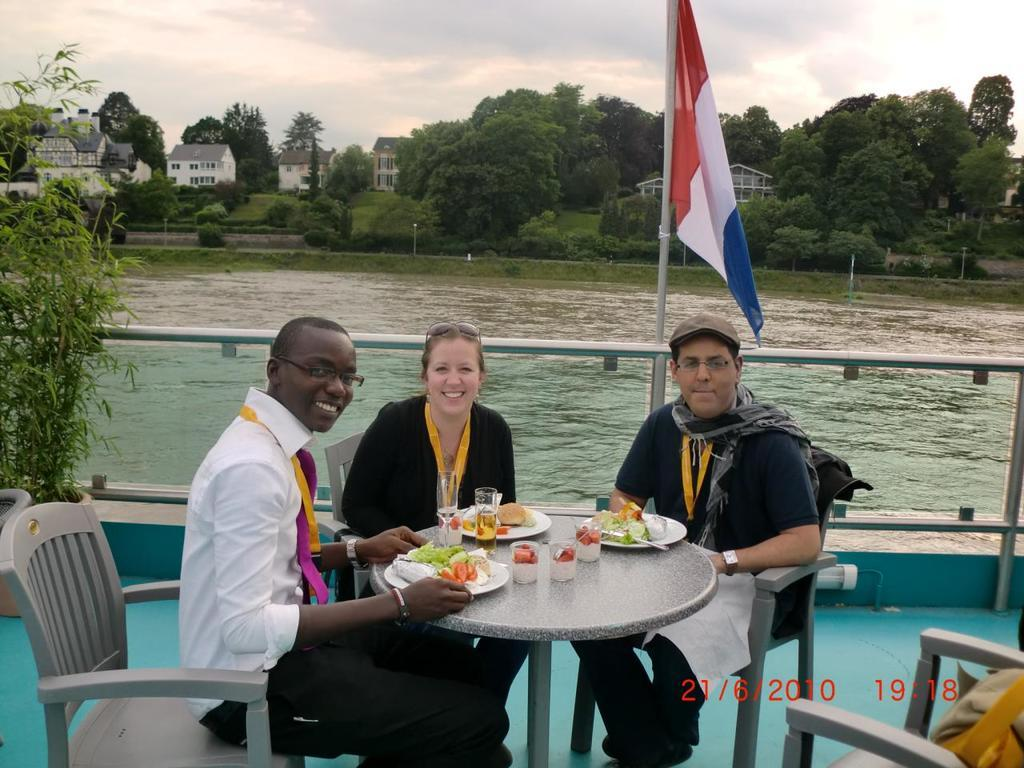How many persons are in the image? There are three persons in the image. What are the persons doing in the image? The persons are sitting on chairs and smiling. What are the persons wearing in the image? The persons are wearing glasses. What can be seen on the table in the image? There are plates, food, and glasses on the table. What is visible in the background of the image? There are trees, houses, sky, a flag, and water visible in the background of the image. Can you tell me where the beggar is sitting in the image? There is no beggar present in the image. What type of tub can be seen in the background of the image? There is no tub visible in the background of the image. 